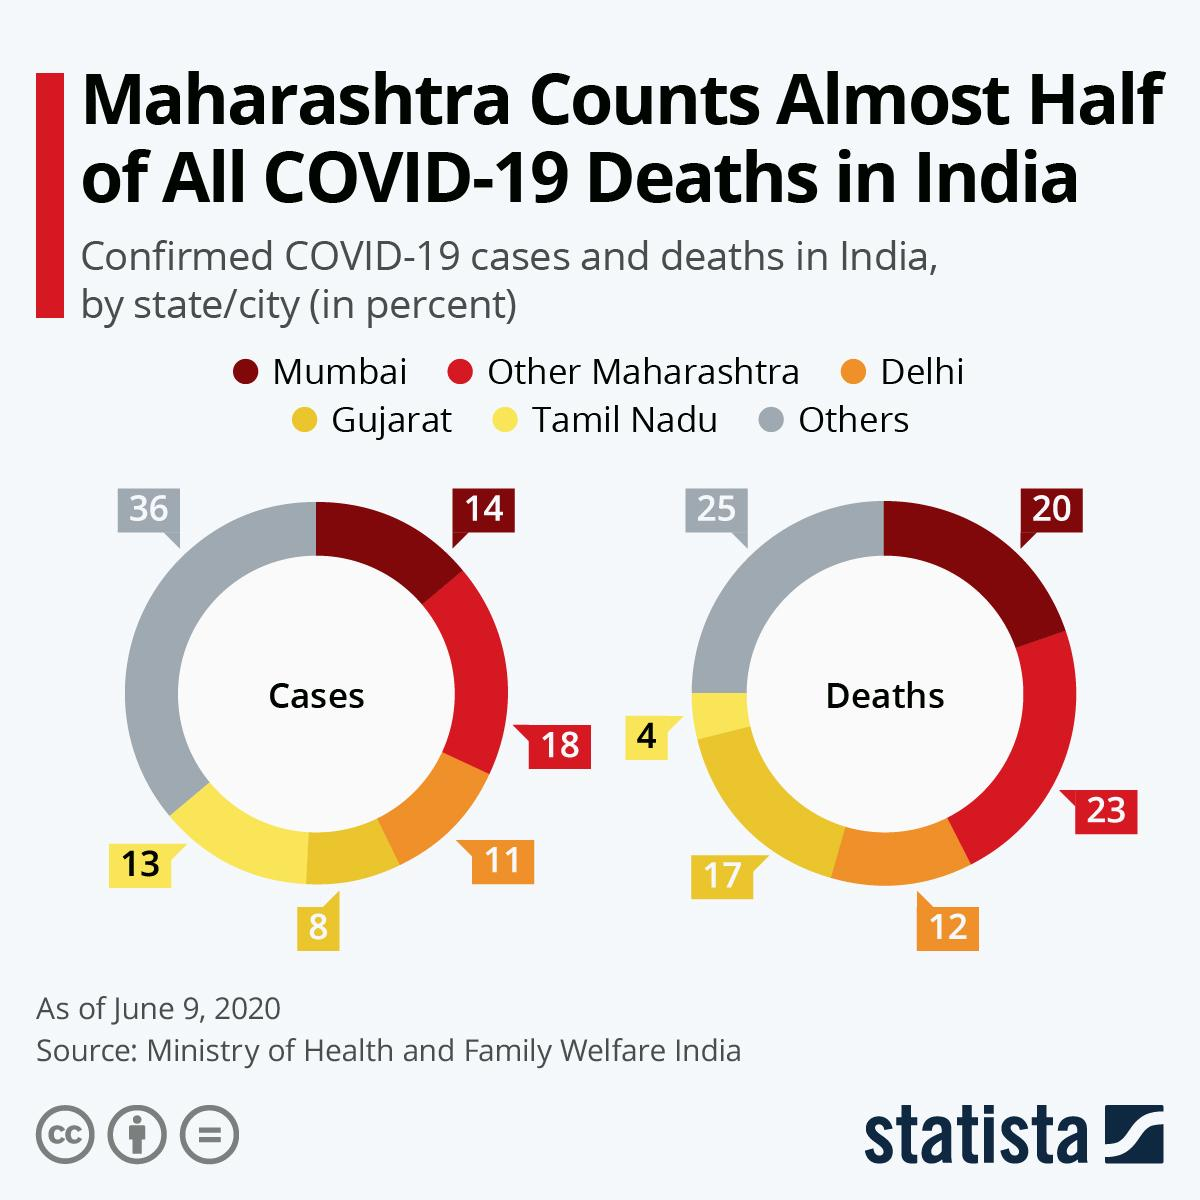Identify some key points in this picture. The place with the second highest number of deaths was Other Maharashtra. Gujarat had the least number of cases among the places listed. 